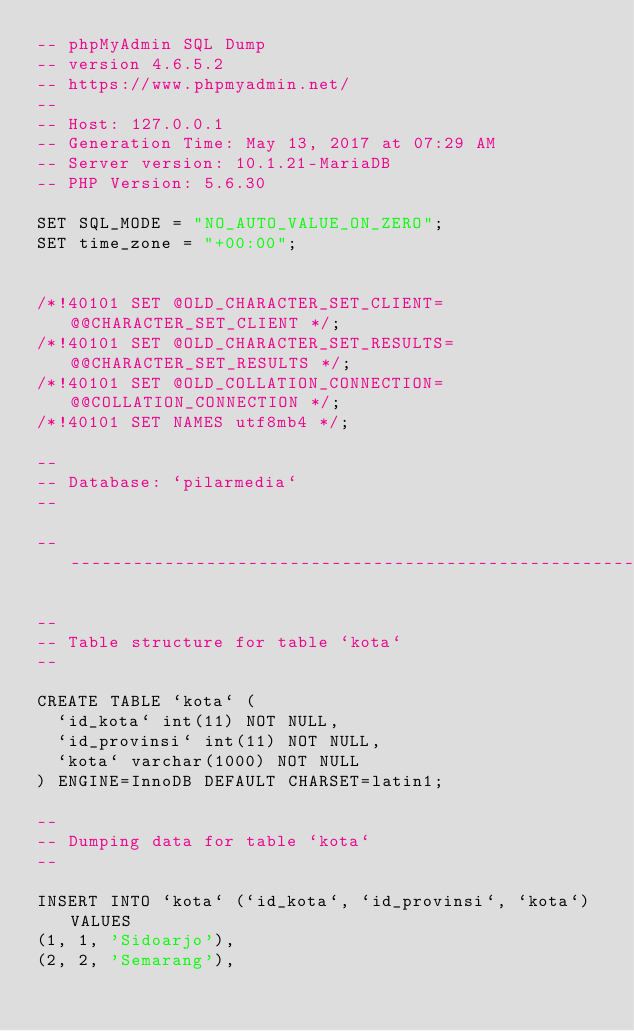<code> <loc_0><loc_0><loc_500><loc_500><_SQL_>-- phpMyAdmin SQL Dump
-- version 4.6.5.2
-- https://www.phpmyadmin.net/
--
-- Host: 127.0.0.1
-- Generation Time: May 13, 2017 at 07:29 AM
-- Server version: 10.1.21-MariaDB
-- PHP Version: 5.6.30

SET SQL_MODE = "NO_AUTO_VALUE_ON_ZERO";
SET time_zone = "+00:00";


/*!40101 SET @OLD_CHARACTER_SET_CLIENT=@@CHARACTER_SET_CLIENT */;
/*!40101 SET @OLD_CHARACTER_SET_RESULTS=@@CHARACTER_SET_RESULTS */;
/*!40101 SET @OLD_COLLATION_CONNECTION=@@COLLATION_CONNECTION */;
/*!40101 SET NAMES utf8mb4 */;

--
-- Database: `pilarmedia`
--

-- --------------------------------------------------------

--
-- Table structure for table `kota`
--

CREATE TABLE `kota` (
  `id_kota` int(11) NOT NULL,
  `id_provinsi` int(11) NOT NULL,
  `kota` varchar(1000) NOT NULL
) ENGINE=InnoDB DEFAULT CHARSET=latin1;

--
-- Dumping data for table `kota`
--

INSERT INTO `kota` (`id_kota`, `id_provinsi`, `kota`) VALUES
(1, 1, 'Sidoarjo'),
(2, 2, 'Semarang'),</code> 